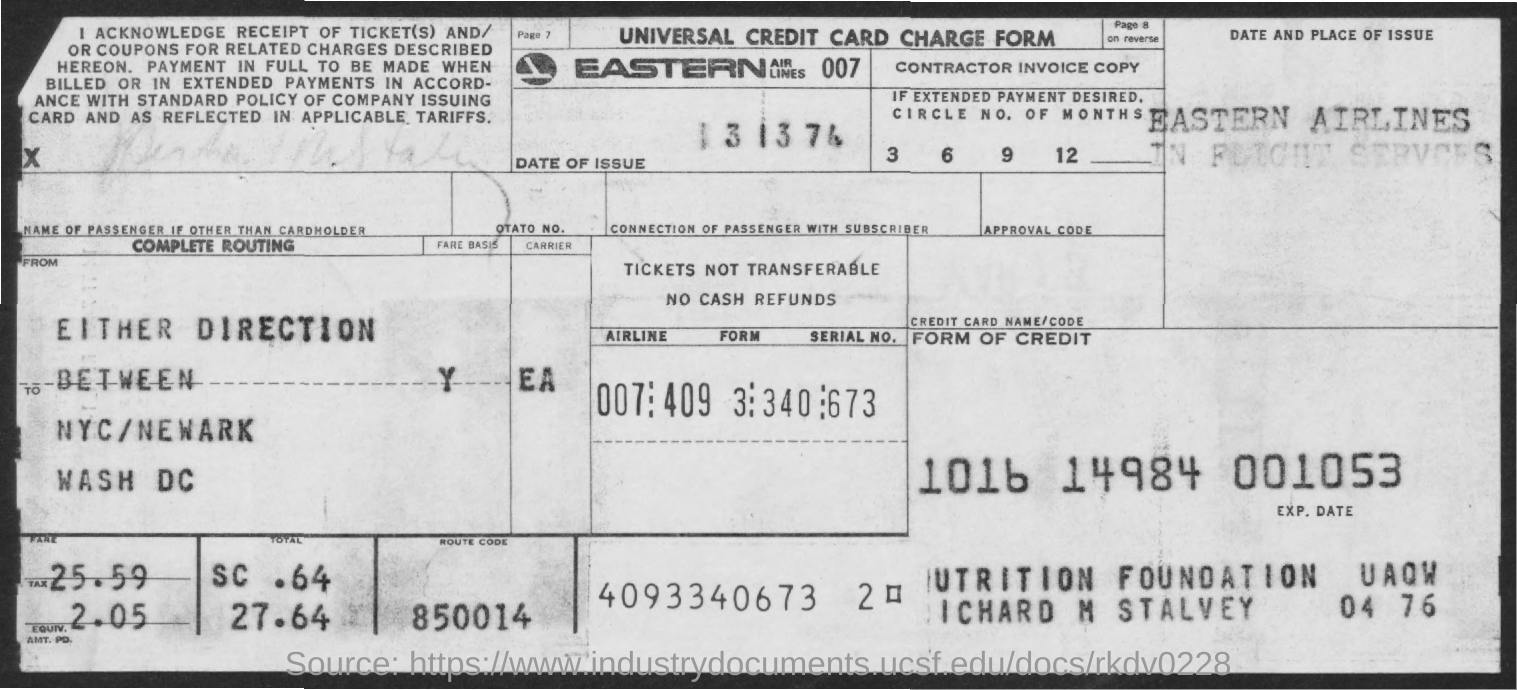What type of document is it?
Give a very brief answer. Universal credit card charge form. Which airlines is mentioned?
Your response must be concise. Eastern Airlines. What is the route code?
Give a very brief answer. 850014. How much is the tax amount?
Offer a terse response. 2.05. How much is the fare amount?
Offer a terse response. 25.59. 